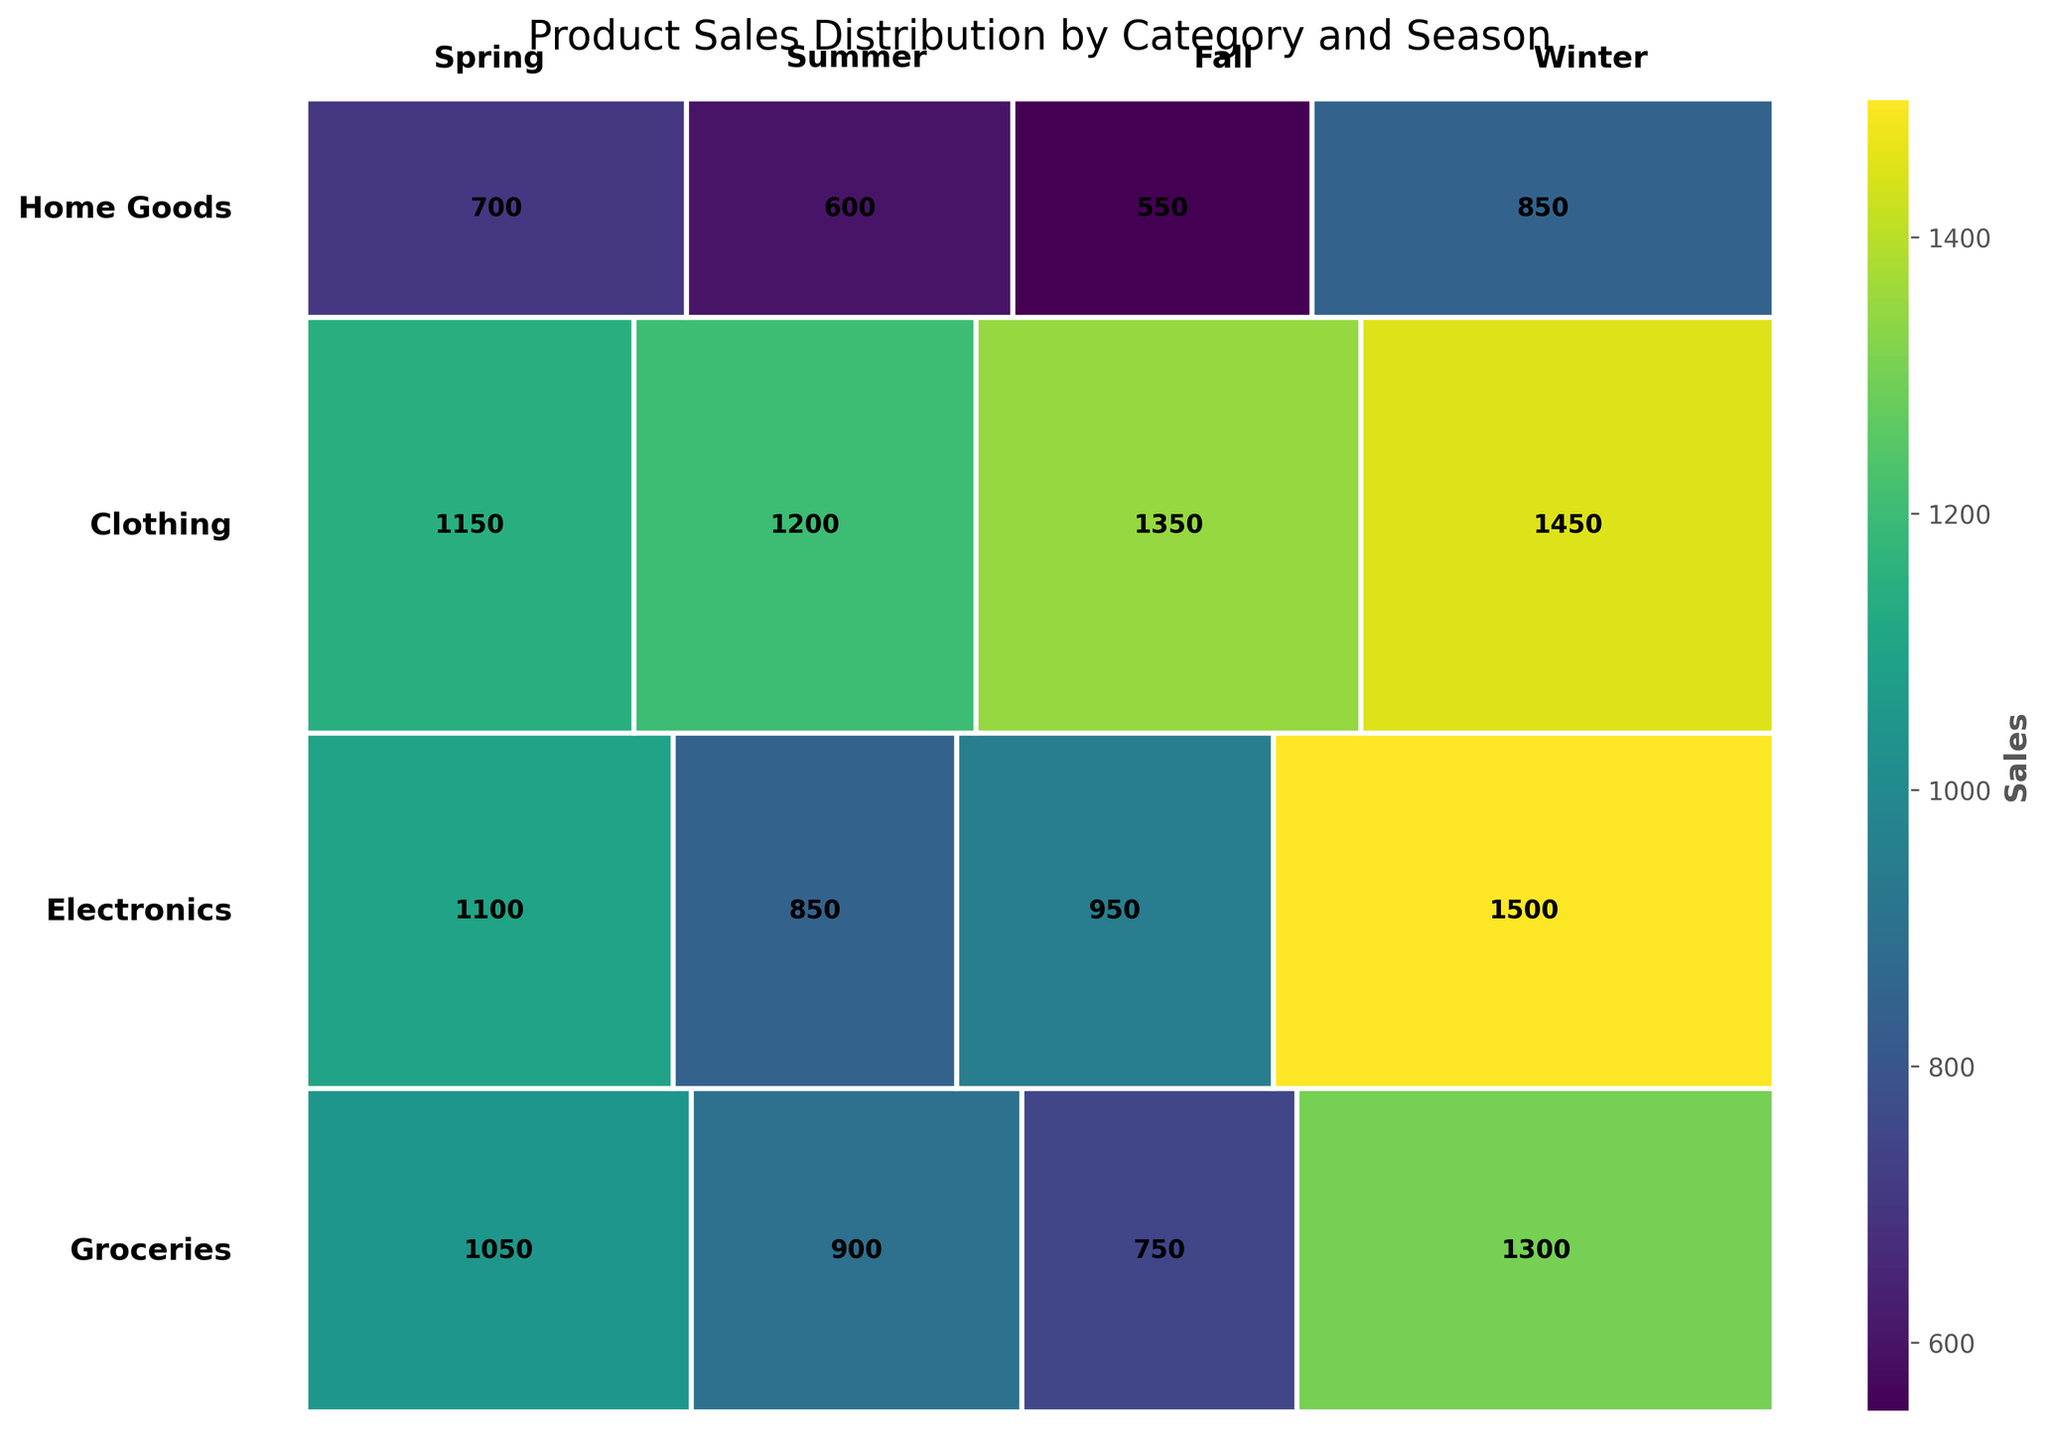What is the title of the plot? The title is typically located at the top of the plot and is usually in a larger and bold font to stand out. In this plot, the title reads "Product Sales Distribution by Category and Season".
Answer: Product Sales Distribution by Category and Season Which category has the highest total sales in the Winter? To find this, look at the rectangle heights for the Winter season and identify the highest one. The category with the highest sales in Winter is Electronics.
Answer: Electronics What are the sales values for Groceries in each season? Locate the Groceries row and read off the sales values within the rectangles for each season. The sales values for Groceries are 1200 for Spring, 1350 for Summer, 1150 for Fall, and 1450 for Winter.
Answer: 1200 (Spring), 1350 (Summer), 1150 (Fall), 1450 (Winter) Compare the sales of Clothing and Home Goods in the Fall. Which one is higher? Identify the sales value rectangles for Clothing and Home Goods in the Fall season. Clothing has a sales value of 1050, whereas Home Goods has a sales value of 700. Clothing's sales are higher.
Answer: Clothing How do the sales of Electronics in Summer compare with those in Winter? Look at the sales rectangles for Electronics in Summer and Winter. Electronics has sales of 950 in Summer and 1500 in Winter. The sales in Winter are higher than in Summer.
Answer: Winter Calculate the total sales for Home Goods across all seasons. Sum the sales for Home Goods in each season: Spring (600), Summer (550), Fall (700), and Winter (850). The total sales are 600 + 550 + 700 + 850 = 2700.
Answer: 2700 Which season has the smallest sales for Groceries? Compare the rectangles for Groceries across all seasons and identify the smallest one. The smallest sales for Groceries are in Fall with a sales value of 1150.
Answer: Fall What is the average sales value for Clothing across all seasons? To find the average, sum the sales values for Clothing in all seasons (900 for Spring, 750 for Summer, 1050 for Fall, 1300 for Winter) and divide by the number of seasons. The sum is 900 + 750 + 1050 + 1300 = 4000, and there are 4 values. The average is 4000/4 = 1000.
Answer: 1000 Which category has the most uniform sales distribution across different seasons? Look at the categories and compare their sales distributions. The uniformity can be identified by similar-sized rectangles across all seasons. Groceries seem to have the most uniform distribution.
Answer: Groceries 